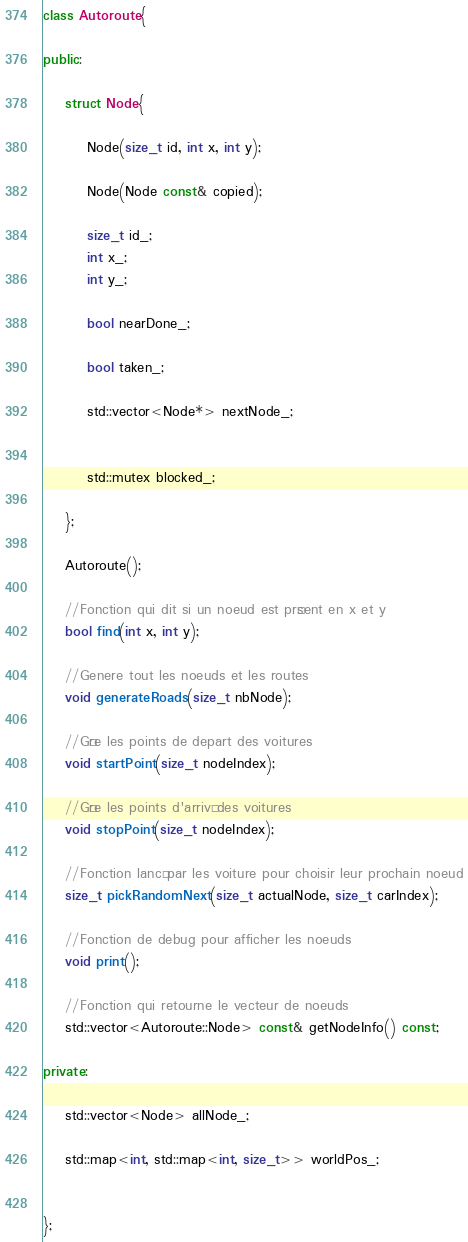Convert code to text. <code><loc_0><loc_0><loc_500><loc_500><_C++_>class Autoroute{

public:

	struct Node{

		Node(size_t id, int x, int y);

		Node(Node const& copied);

		size_t id_;
		int x_;
		int y_;

		bool nearDone_;

		bool taken_;

		std::vector<Node*> nextNode_;


		std::mutex blocked_;

	};
	
	Autoroute();

	//Fonction qui dit si un noeud est présent en x et y
	bool find(int x, int y);

	//Genere tout les noeuds et les routes
	void generateRoads(size_t nbNode);

	//Gère les points de depart des voitures
	void startPoint(size_t nodeIndex);

	//Gère les points d'arrivé des voitures
	void stopPoint(size_t nodeIndex);

	//Fonction lancé par les voiture pour choisir leur prochain noeud
	size_t pickRandomNext(size_t actualNode, size_t carIndex);

	//Fonction de debug pour afficher les noeuds
	void print();

	//Fonction qui retourne le vecteur de noeuds
	std::vector<Autoroute::Node> const& getNodeInfo() const;
	
private:

	std::vector<Node> allNode_;

	std::map<int, std::map<int, size_t>> worldPos_;


};</code> 